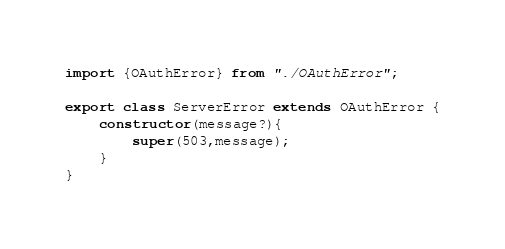Convert code to text. <code><loc_0><loc_0><loc_500><loc_500><_TypeScript_>import {OAuthError} from "./OAuthError";

export class ServerError extends OAuthError {
    constructor(message?){
        super(503,message);
    }
}</code> 